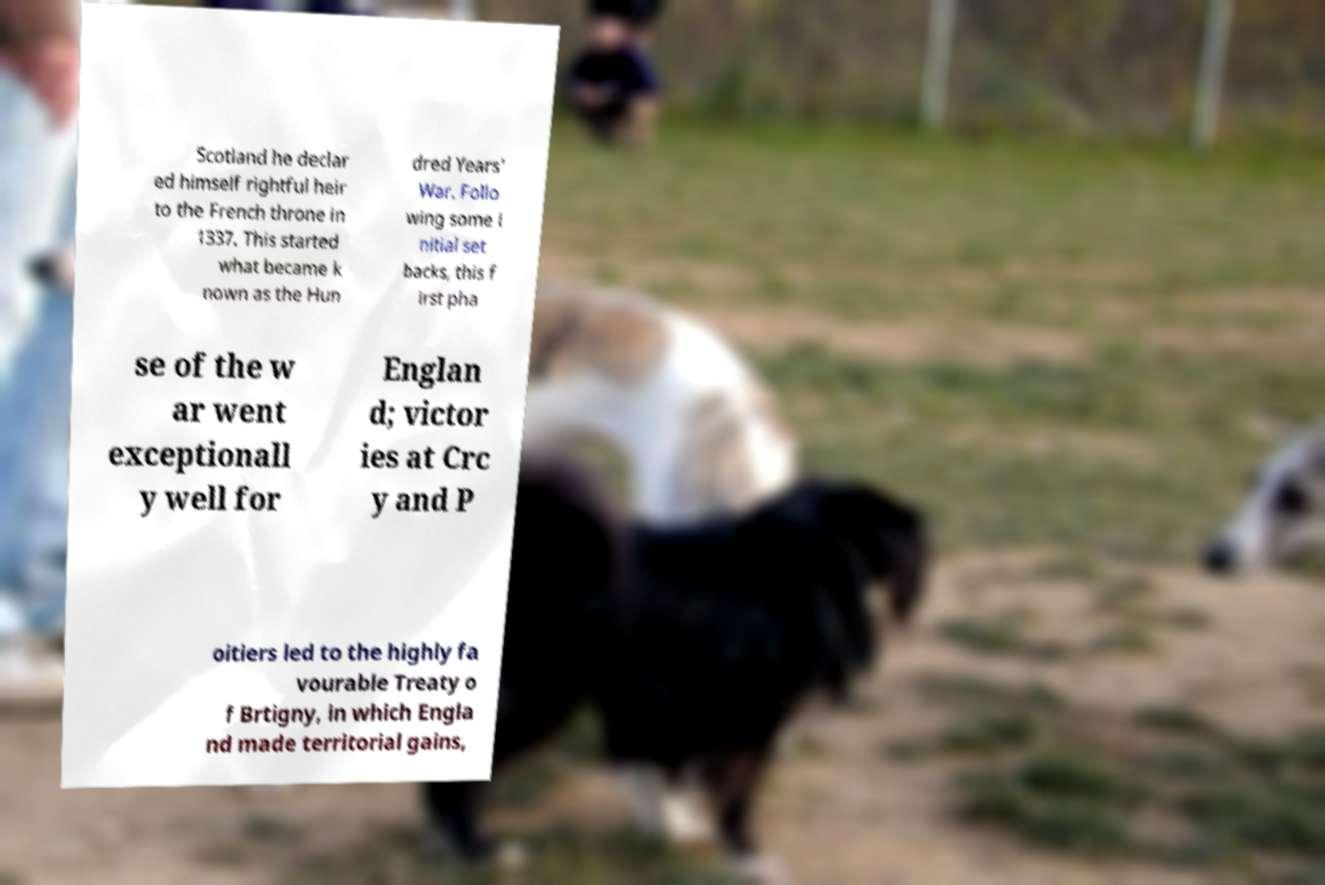Please read and relay the text visible in this image. What does it say? Scotland he declar ed himself rightful heir to the French throne in 1337. This started what became k nown as the Hun dred Years' War. Follo wing some i nitial set backs, this f irst pha se of the w ar went exceptionall y well for Englan d; victor ies at Crc y and P oitiers led to the highly fa vourable Treaty o f Brtigny, in which Engla nd made territorial gains, 